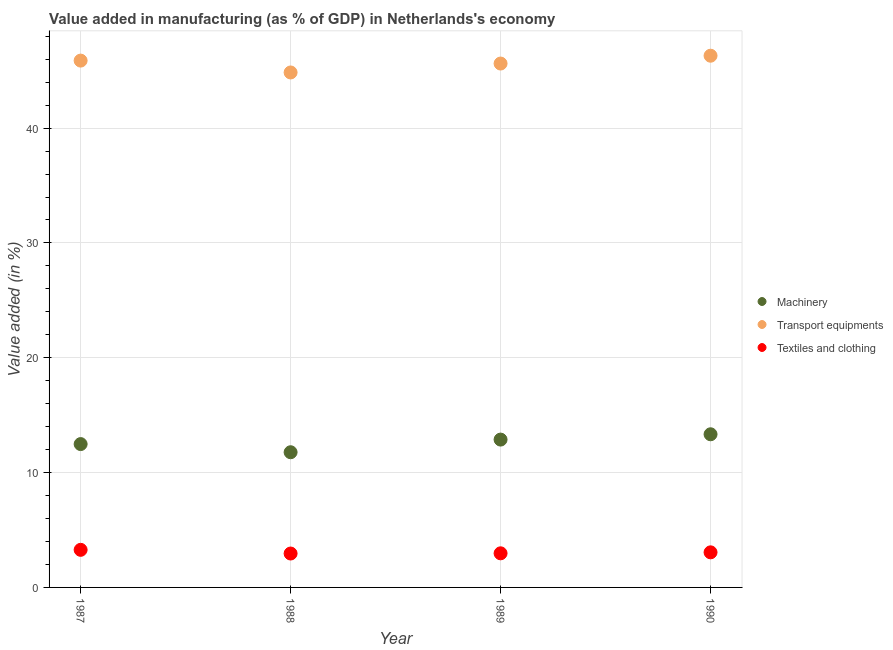How many different coloured dotlines are there?
Give a very brief answer. 3. Is the number of dotlines equal to the number of legend labels?
Provide a succinct answer. Yes. What is the value added in manufacturing textile and clothing in 1989?
Ensure brevity in your answer.  2.97. Across all years, what is the maximum value added in manufacturing machinery?
Keep it short and to the point. 13.34. Across all years, what is the minimum value added in manufacturing textile and clothing?
Offer a terse response. 2.95. In which year was the value added in manufacturing machinery maximum?
Your answer should be compact. 1990. What is the total value added in manufacturing machinery in the graph?
Your response must be concise. 50.47. What is the difference between the value added in manufacturing transport equipments in 1987 and that in 1989?
Give a very brief answer. 0.26. What is the difference between the value added in manufacturing transport equipments in 1987 and the value added in manufacturing textile and clothing in 1990?
Provide a succinct answer. 42.82. What is the average value added in manufacturing textile and clothing per year?
Offer a very short reply. 3.06. In the year 1990, what is the difference between the value added in manufacturing transport equipments and value added in manufacturing machinery?
Provide a short and direct response. 32.97. In how many years, is the value added in manufacturing textile and clothing greater than 46 %?
Your answer should be compact. 0. What is the ratio of the value added in manufacturing machinery in 1987 to that in 1988?
Your response must be concise. 1.06. Is the value added in manufacturing machinery in 1988 less than that in 1990?
Make the answer very short. Yes. What is the difference between the highest and the second highest value added in manufacturing textile and clothing?
Your response must be concise. 0.22. What is the difference between the highest and the lowest value added in manufacturing machinery?
Give a very brief answer. 1.56. In how many years, is the value added in manufacturing machinery greater than the average value added in manufacturing machinery taken over all years?
Your answer should be very brief. 2. Is the value added in manufacturing machinery strictly greater than the value added in manufacturing textile and clothing over the years?
Keep it short and to the point. Yes. How many dotlines are there?
Give a very brief answer. 3. Are the values on the major ticks of Y-axis written in scientific E-notation?
Your answer should be very brief. No. Does the graph contain any zero values?
Your answer should be compact. No. Does the graph contain grids?
Your answer should be very brief. Yes. Where does the legend appear in the graph?
Offer a terse response. Center right. How many legend labels are there?
Ensure brevity in your answer.  3. How are the legend labels stacked?
Your response must be concise. Vertical. What is the title of the graph?
Your response must be concise. Value added in manufacturing (as % of GDP) in Netherlands's economy. Does "Nuclear sources" appear as one of the legend labels in the graph?
Your response must be concise. No. What is the label or title of the X-axis?
Keep it short and to the point. Year. What is the label or title of the Y-axis?
Keep it short and to the point. Value added (in %). What is the Value added (in %) in Machinery in 1987?
Your response must be concise. 12.48. What is the Value added (in %) of Transport equipments in 1987?
Your response must be concise. 45.88. What is the Value added (in %) of Textiles and clothing in 1987?
Your answer should be compact. 3.27. What is the Value added (in %) of Machinery in 1988?
Offer a very short reply. 11.77. What is the Value added (in %) of Transport equipments in 1988?
Keep it short and to the point. 44.85. What is the Value added (in %) of Textiles and clothing in 1988?
Your response must be concise. 2.95. What is the Value added (in %) of Machinery in 1989?
Provide a short and direct response. 12.88. What is the Value added (in %) in Transport equipments in 1989?
Your answer should be compact. 45.63. What is the Value added (in %) in Textiles and clothing in 1989?
Offer a terse response. 2.97. What is the Value added (in %) in Machinery in 1990?
Your answer should be very brief. 13.34. What is the Value added (in %) in Transport equipments in 1990?
Provide a succinct answer. 46.31. What is the Value added (in %) of Textiles and clothing in 1990?
Offer a very short reply. 3.06. Across all years, what is the maximum Value added (in %) in Machinery?
Your answer should be compact. 13.34. Across all years, what is the maximum Value added (in %) of Transport equipments?
Make the answer very short. 46.31. Across all years, what is the maximum Value added (in %) of Textiles and clothing?
Provide a short and direct response. 3.27. Across all years, what is the minimum Value added (in %) of Machinery?
Give a very brief answer. 11.77. Across all years, what is the minimum Value added (in %) in Transport equipments?
Your response must be concise. 44.85. Across all years, what is the minimum Value added (in %) of Textiles and clothing?
Ensure brevity in your answer.  2.95. What is the total Value added (in %) in Machinery in the graph?
Keep it short and to the point. 50.47. What is the total Value added (in %) of Transport equipments in the graph?
Give a very brief answer. 182.66. What is the total Value added (in %) of Textiles and clothing in the graph?
Provide a succinct answer. 12.25. What is the difference between the Value added (in %) of Machinery in 1987 and that in 1988?
Your answer should be very brief. 0.71. What is the difference between the Value added (in %) of Transport equipments in 1987 and that in 1988?
Your response must be concise. 1.03. What is the difference between the Value added (in %) of Textiles and clothing in 1987 and that in 1988?
Offer a terse response. 0.32. What is the difference between the Value added (in %) of Machinery in 1987 and that in 1989?
Your answer should be compact. -0.39. What is the difference between the Value added (in %) in Transport equipments in 1987 and that in 1989?
Offer a very short reply. 0.26. What is the difference between the Value added (in %) in Textiles and clothing in 1987 and that in 1989?
Your answer should be compact. 0.3. What is the difference between the Value added (in %) of Machinery in 1987 and that in 1990?
Provide a succinct answer. -0.85. What is the difference between the Value added (in %) in Transport equipments in 1987 and that in 1990?
Your response must be concise. -0.43. What is the difference between the Value added (in %) of Textiles and clothing in 1987 and that in 1990?
Your answer should be compact. 0.22. What is the difference between the Value added (in %) of Machinery in 1988 and that in 1989?
Your answer should be compact. -1.1. What is the difference between the Value added (in %) of Transport equipments in 1988 and that in 1989?
Make the answer very short. -0.78. What is the difference between the Value added (in %) of Textiles and clothing in 1988 and that in 1989?
Offer a terse response. -0.02. What is the difference between the Value added (in %) of Machinery in 1988 and that in 1990?
Offer a terse response. -1.56. What is the difference between the Value added (in %) of Transport equipments in 1988 and that in 1990?
Your response must be concise. -1.46. What is the difference between the Value added (in %) in Textiles and clothing in 1988 and that in 1990?
Give a very brief answer. -0.1. What is the difference between the Value added (in %) of Machinery in 1989 and that in 1990?
Your answer should be very brief. -0.46. What is the difference between the Value added (in %) of Transport equipments in 1989 and that in 1990?
Make the answer very short. -0.68. What is the difference between the Value added (in %) in Textiles and clothing in 1989 and that in 1990?
Provide a short and direct response. -0.09. What is the difference between the Value added (in %) of Machinery in 1987 and the Value added (in %) of Transport equipments in 1988?
Keep it short and to the point. -32.36. What is the difference between the Value added (in %) of Machinery in 1987 and the Value added (in %) of Textiles and clothing in 1988?
Keep it short and to the point. 9.53. What is the difference between the Value added (in %) of Transport equipments in 1987 and the Value added (in %) of Textiles and clothing in 1988?
Provide a succinct answer. 42.93. What is the difference between the Value added (in %) of Machinery in 1987 and the Value added (in %) of Transport equipments in 1989?
Offer a very short reply. -33.14. What is the difference between the Value added (in %) of Machinery in 1987 and the Value added (in %) of Textiles and clothing in 1989?
Your answer should be very brief. 9.51. What is the difference between the Value added (in %) of Transport equipments in 1987 and the Value added (in %) of Textiles and clothing in 1989?
Give a very brief answer. 42.91. What is the difference between the Value added (in %) of Machinery in 1987 and the Value added (in %) of Transport equipments in 1990?
Your answer should be compact. -33.82. What is the difference between the Value added (in %) of Machinery in 1987 and the Value added (in %) of Textiles and clothing in 1990?
Your response must be concise. 9.43. What is the difference between the Value added (in %) in Transport equipments in 1987 and the Value added (in %) in Textiles and clothing in 1990?
Offer a very short reply. 42.82. What is the difference between the Value added (in %) in Machinery in 1988 and the Value added (in %) in Transport equipments in 1989?
Provide a short and direct response. -33.85. What is the difference between the Value added (in %) of Machinery in 1988 and the Value added (in %) of Textiles and clothing in 1989?
Offer a very short reply. 8.8. What is the difference between the Value added (in %) in Transport equipments in 1988 and the Value added (in %) in Textiles and clothing in 1989?
Keep it short and to the point. 41.88. What is the difference between the Value added (in %) in Machinery in 1988 and the Value added (in %) in Transport equipments in 1990?
Offer a terse response. -34.53. What is the difference between the Value added (in %) of Machinery in 1988 and the Value added (in %) of Textiles and clothing in 1990?
Provide a short and direct response. 8.72. What is the difference between the Value added (in %) of Transport equipments in 1988 and the Value added (in %) of Textiles and clothing in 1990?
Make the answer very short. 41.79. What is the difference between the Value added (in %) in Machinery in 1989 and the Value added (in %) in Transport equipments in 1990?
Offer a very short reply. -33.43. What is the difference between the Value added (in %) of Machinery in 1989 and the Value added (in %) of Textiles and clothing in 1990?
Your response must be concise. 9.82. What is the difference between the Value added (in %) in Transport equipments in 1989 and the Value added (in %) in Textiles and clothing in 1990?
Ensure brevity in your answer.  42.57. What is the average Value added (in %) in Machinery per year?
Your answer should be compact. 12.62. What is the average Value added (in %) of Transport equipments per year?
Provide a short and direct response. 45.67. What is the average Value added (in %) in Textiles and clothing per year?
Make the answer very short. 3.06. In the year 1987, what is the difference between the Value added (in %) in Machinery and Value added (in %) in Transport equipments?
Offer a very short reply. -33.4. In the year 1987, what is the difference between the Value added (in %) of Machinery and Value added (in %) of Textiles and clothing?
Keep it short and to the point. 9.21. In the year 1987, what is the difference between the Value added (in %) of Transport equipments and Value added (in %) of Textiles and clothing?
Provide a succinct answer. 42.61. In the year 1988, what is the difference between the Value added (in %) of Machinery and Value added (in %) of Transport equipments?
Your response must be concise. -33.07. In the year 1988, what is the difference between the Value added (in %) of Machinery and Value added (in %) of Textiles and clothing?
Provide a short and direct response. 8.82. In the year 1988, what is the difference between the Value added (in %) in Transport equipments and Value added (in %) in Textiles and clothing?
Your response must be concise. 41.9. In the year 1989, what is the difference between the Value added (in %) in Machinery and Value added (in %) in Transport equipments?
Provide a succinct answer. -32.75. In the year 1989, what is the difference between the Value added (in %) of Machinery and Value added (in %) of Textiles and clothing?
Provide a short and direct response. 9.9. In the year 1989, what is the difference between the Value added (in %) in Transport equipments and Value added (in %) in Textiles and clothing?
Offer a very short reply. 42.65. In the year 1990, what is the difference between the Value added (in %) of Machinery and Value added (in %) of Transport equipments?
Give a very brief answer. -32.97. In the year 1990, what is the difference between the Value added (in %) of Machinery and Value added (in %) of Textiles and clothing?
Ensure brevity in your answer.  10.28. In the year 1990, what is the difference between the Value added (in %) of Transport equipments and Value added (in %) of Textiles and clothing?
Offer a very short reply. 43.25. What is the ratio of the Value added (in %) in Machinery in 1987 to that in 1988?
Give a very brief answer. 1.06. What is the ratio of the Value added (in %) of Transport equipments in 1987 to that in 1988?
Provide a short and direct response. 1.02. What is the ratio of the Value added (in %) of Textiles and clothing in 1987 to that in 1988?
Offer a terse response. 1.11. What is the ratio of the Value added (in %) of Machinery in 1987 to that in 1989?
Ensure brevity in your answer.  0.97. What is the ratio of the Value added (in %) in Transport equipments in 1987 to that in 1989?
Your answer should be compact. 1.01. What is the ratio of the Value added (in %) in Textiles and clothing in 1987 to that in 1989?
Your answer should be very brief. 1.1. What is the ratio of the Value added (in %) in Machinery in 1987 to that in 1990?
Make the answer very short. 0.94. What is the ratio of the Value added (in %) in Transport equipments in 1987 to that in 1990?
Offer a very short reply. 0.99. What is the ratio of the Value added (in %) of Textiles and clothing in 1987 to that in 1990?
Provide a short and direct response. 1.07. What is the ratio of the Value added (in %) in Machinery in 1988 to that in 1989?
Give a very brief answer. 0.91. What is the ratio of the Value added (in %) of Transport equipments in 1988 to that in 1989?
Offer a very short reply. 0.98. What is the ratio of the Value added (in %) in Textiles and clothing in 1988 to that in 1989?
Provide a succinct answer. 0.99. What is the ratio of the Value added (in %) in Machinery in 1988 to that in 1990?
Offer a terse response. 0.88. What is the ratio of the Value added (in %) in Transport equipments in 1988 to that in 1990?
Make the answer very short. 0.97. What is the ratio of the Value added (in %) in Textiles and clothing in 1988 to that in 1990?
Your response must be concise. 0.97. What is the ratio of the Value added (in %) of Machinery in 1989 to that in 1990?
Your response must be concise. 0.97. What is the ratio of the Value added (in %) in Textiles and clothing in 1989 to that in 1990?
Ensure brevity in your answer.  0.97. What is the difference between the highest and the second highest Value added (in %) in Machinery?
Ensure brevity in your answer.  0.46. What is the difference between the highest and the second highest Value added (in %) in Transport equipments?
Your response must be concise. 0.43. What is the difference between the highest and the second highest Value added (in %) of Textiles and clothing?
Offer a terse response. 0.22. What is the difference between the highest and the lowest Value added (in %) in Machinery?
Provide a succinct answer. 1.56. What is the difference between the highest and the lowest Value added (in %) of Transport equipments?
Offer a terse response. 1.46. What is the difference between the highest and the lowest Value added (in %) of Textiles and clothing?
Your answer should be very brief. 0.32. 